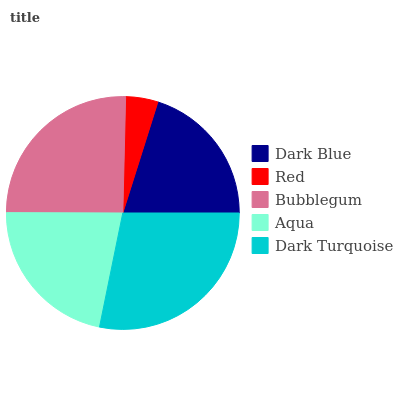Is Red the minimum?
Answer yes or no. Yes. Is Dark Turquoise the maximum?
Answer yes or no. Yes. Is Bubblegum the minimum?
Answer yes or no. No. Is Bubblegum the maximum?
Answer yes or no. No. Is Bubblegum greater than Red?
Answer yes or no. Yes. Is Red less than Bubblegum?
Answer yes or no. Yes. Is Red greater than Bubblegum?
Answer yes or no. No. Is Bubblegum less than Red?
Answer yes or no. No. Is Aqua the high median?
Answer yes or no. Yes. Is Aqua the low median?
Answer yes or no. Yes. Is Bubblegum the high median?
Answer yes or no. No. Is Red the low median?
Answer yes or no. No. 